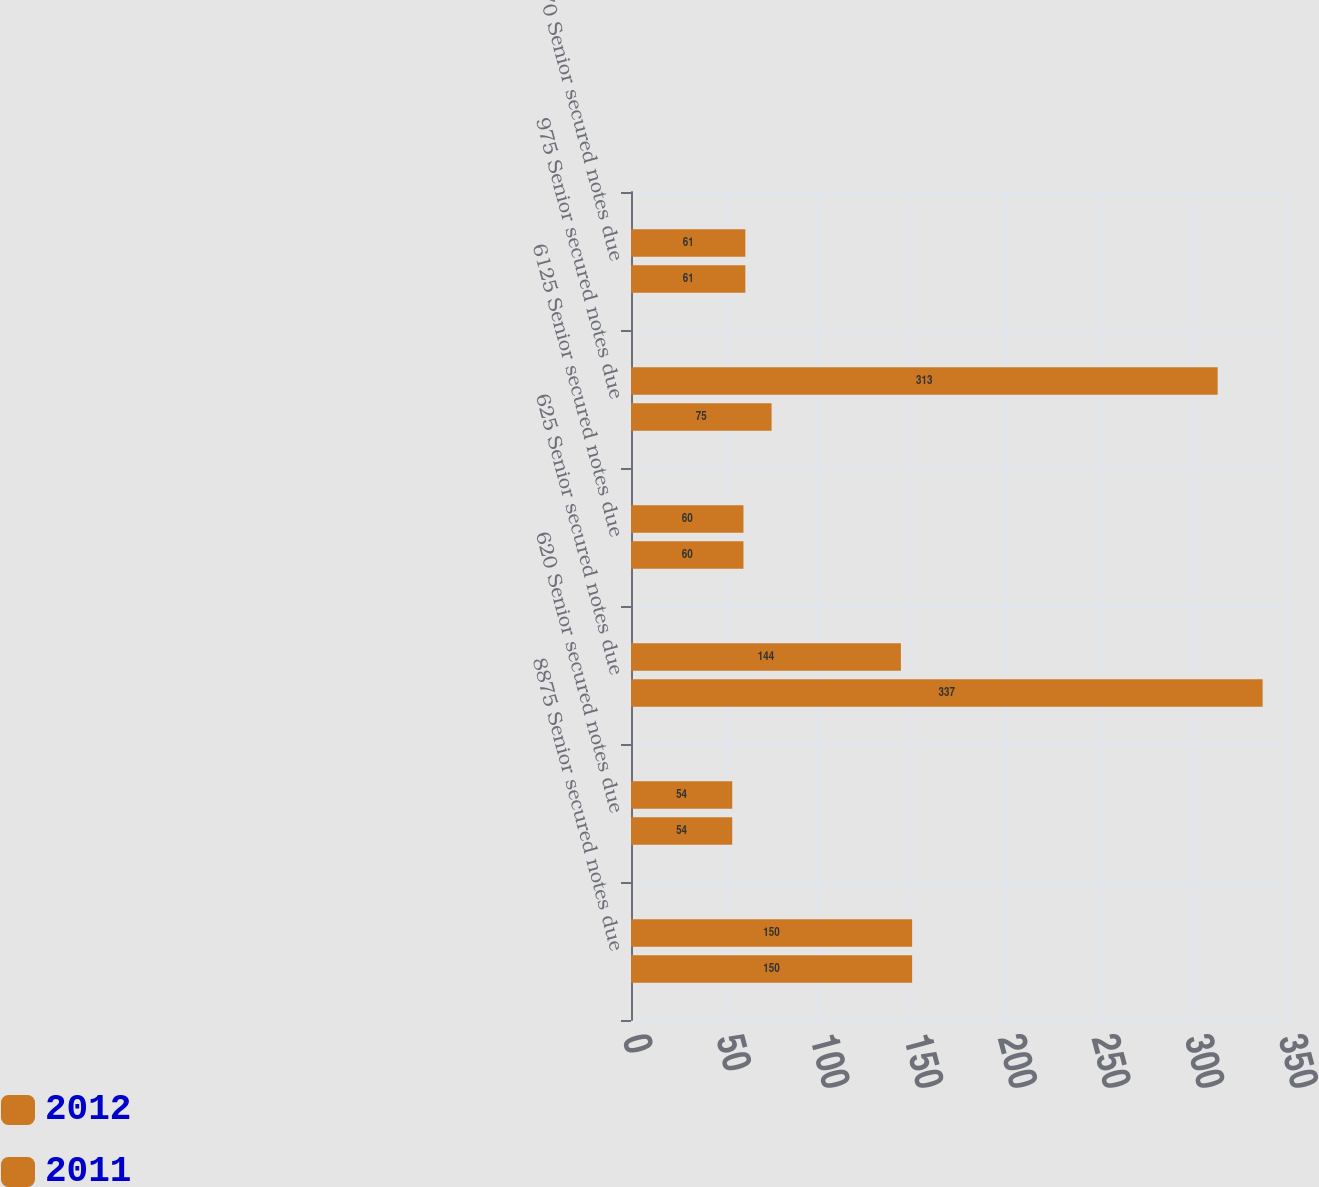Convert chart. <chart><loc_0><loc_0><loc_500><loc_500><stacked_bar_chart><ecel><fcel>8875 Senior secured notes due<fcel>620 Senior secured notes due<fcel>625 Senior secured notes due<fcel>6125 Senior secured notes due<fcel>975 Senior secured notes due<fcel>670 Senior secured notes due<nl><fcel>2012<fcel>150<fcel>54<fcel>144<fcel>60<fcel>313<fcel>61<nl><fcel>2011<fcel>150<fcel>54<fcel>337<fcel>60<fcel>75<fcel>61<nl></chart> 